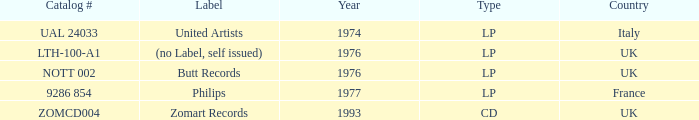What is the earliest year catalog # ual 24033 had an LP? 1974.0. 